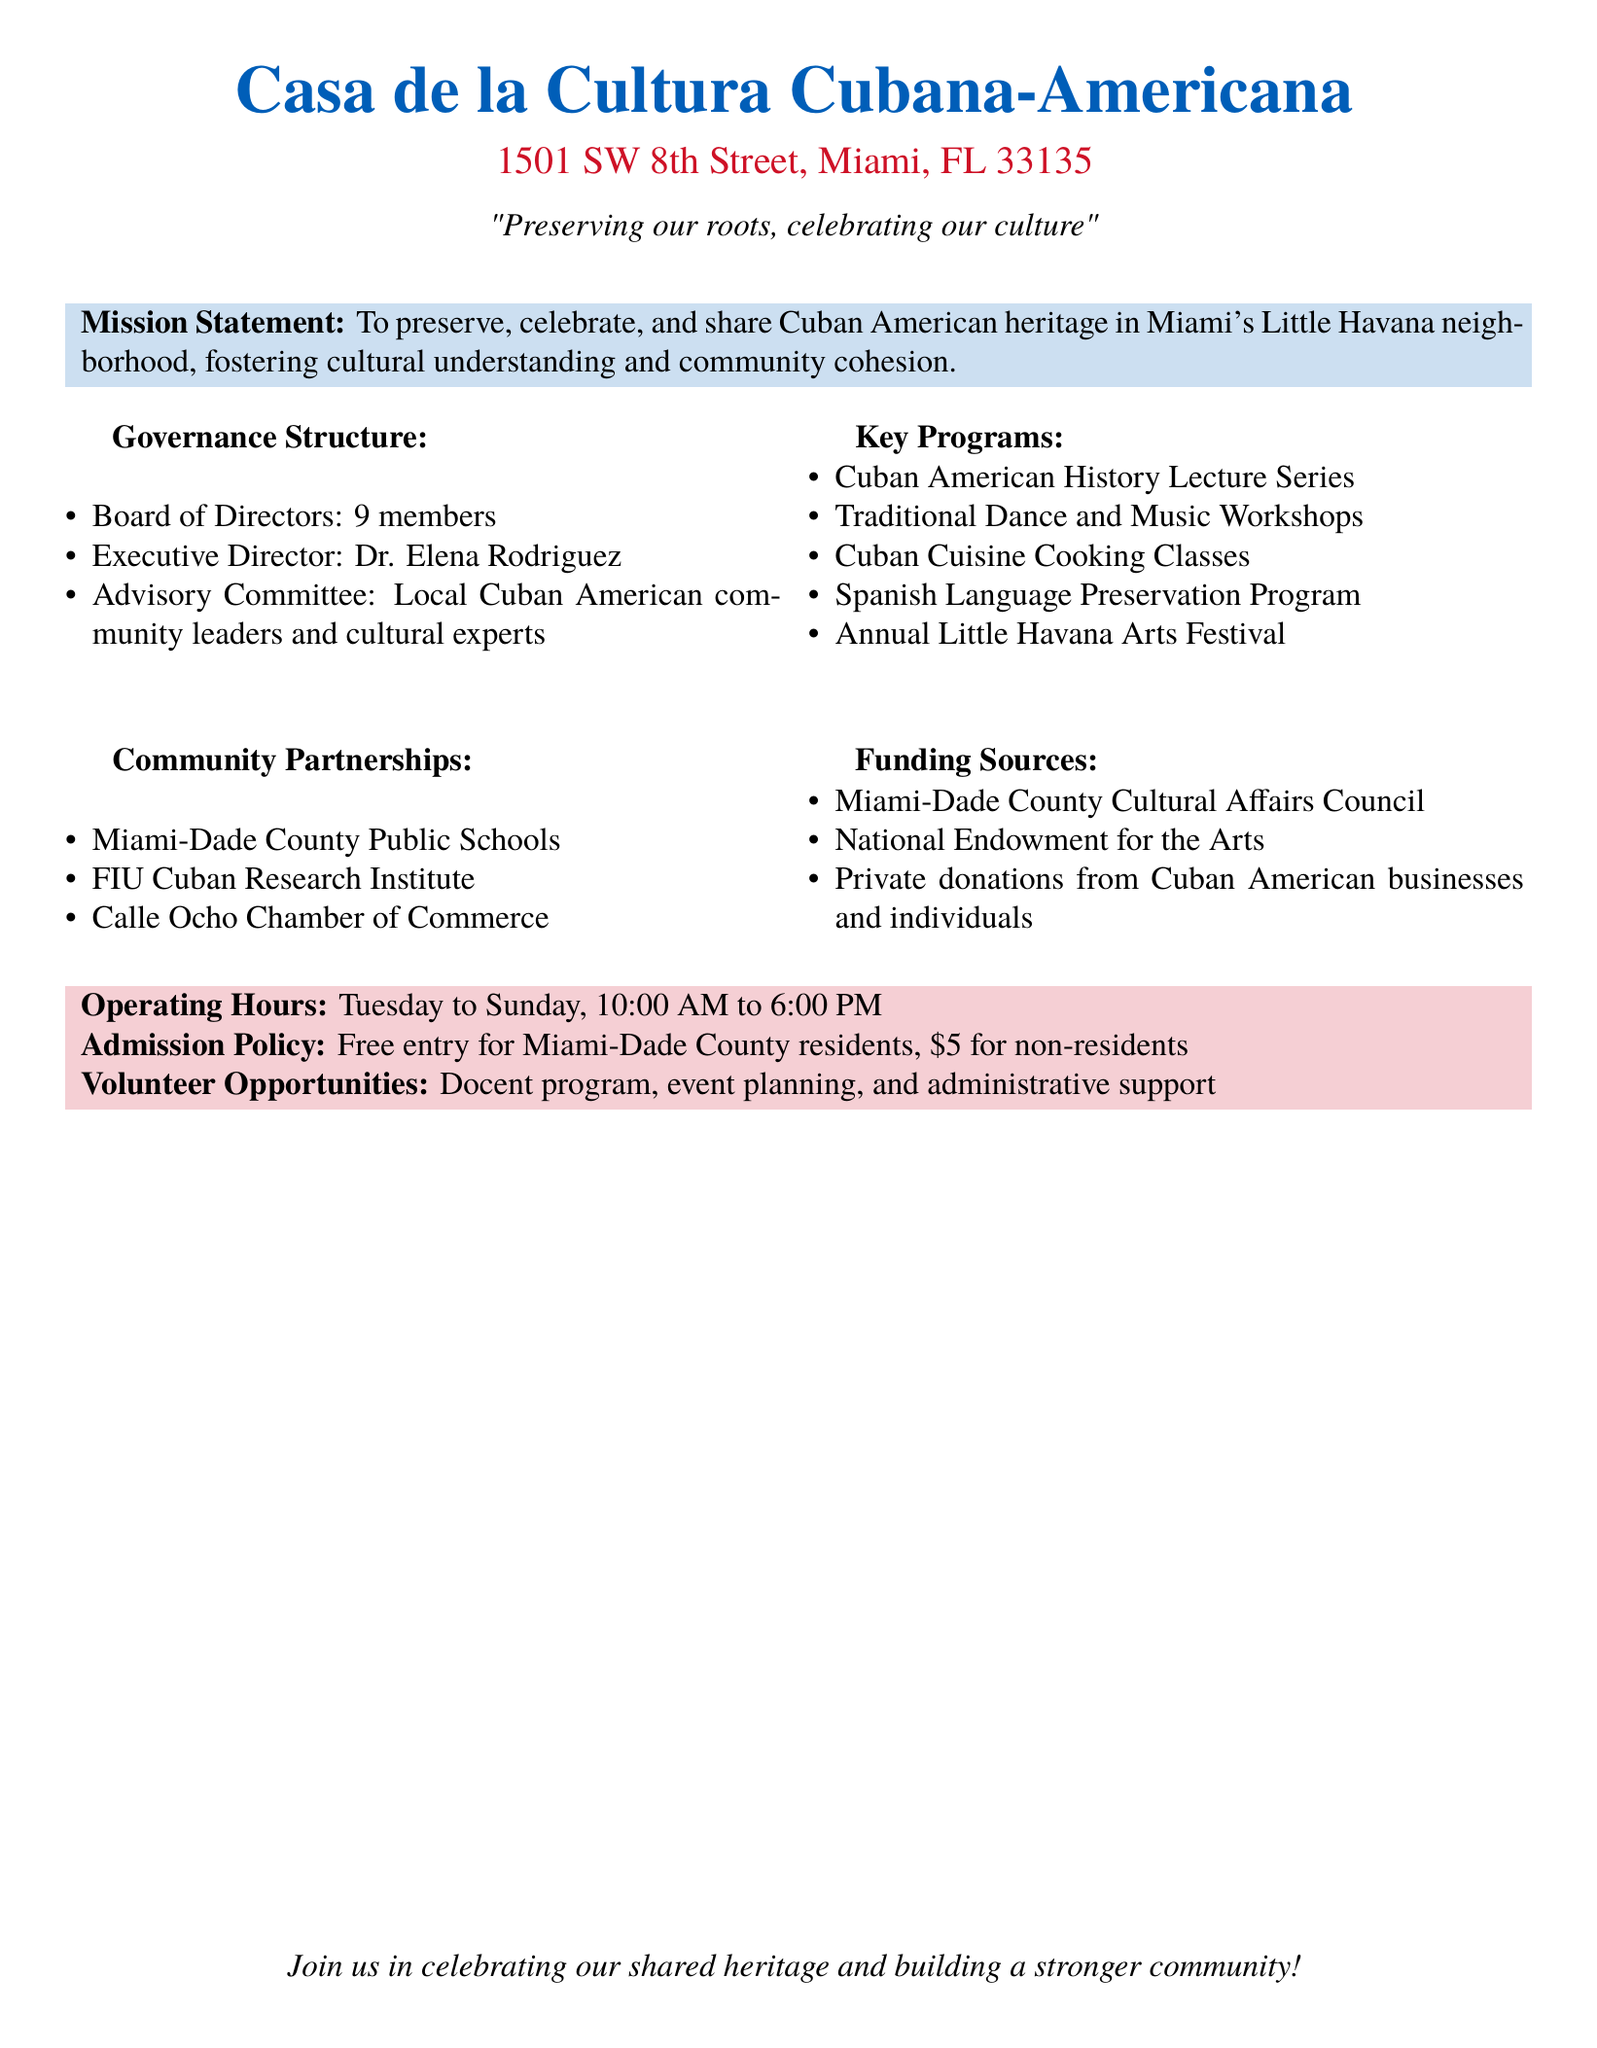What is the mission statement of the center? The mission statement outlines the purpose of the center, which is to preserve, celebrate, and share Cuban American heritage in Miami's Little Havana neighborhood.
Answer: To preserve, celebrate, and share Cuban American heritage in Miami's Little Havana neighborhood Who is the Executive Director of the center? The Executive Director is the individual responsible for overseeing the operations of the center, and the document specifies that this role is filled by Dr. Elena Rodriguez.
Answer: Dr. Elena Rodriguez How many members are on the Board of Directors? The document states the number of members on the Board of Directors, which is important for understanding the governance of the center.
Answer: 9 members What programs focus on Cuban culture at the center? The specific programs listed in the document provide insights into the cultural offerings of the center, with an emphasis on Cuban traditions.
Answer: Cuban American History Lecture Series, Traditional Dance and Music Workshops, Cuban Cuisine Cooking Classes, Spanish Language Preservation Program, Annual Little Havana Arts Festival What is the admission cost for non-residents? The document mentions the admission policy, giving specific fees for different groups, which is important for visitor information.
Answer: $5 for non-residents Which educational institution is a community partner? The community partnership section of the document highlights collaborations, and this question focuses on one of those partners, enhancing understanding of the center's connections.
Answer: FIU Cuban Research Institute What are the operating hours of the center? The operating hours provide essential information for visitors planning their visit to the center, as outlined in the document.
Answer: Tuesday to Sunday, 10:00 AM to 6:00 PM What type of volunteer opportunities are available? This question focuses on the volunteer aspect of the center, highlighting community engagement, as stated in the document.
Answer: Docent program, event planning, and administrative support 